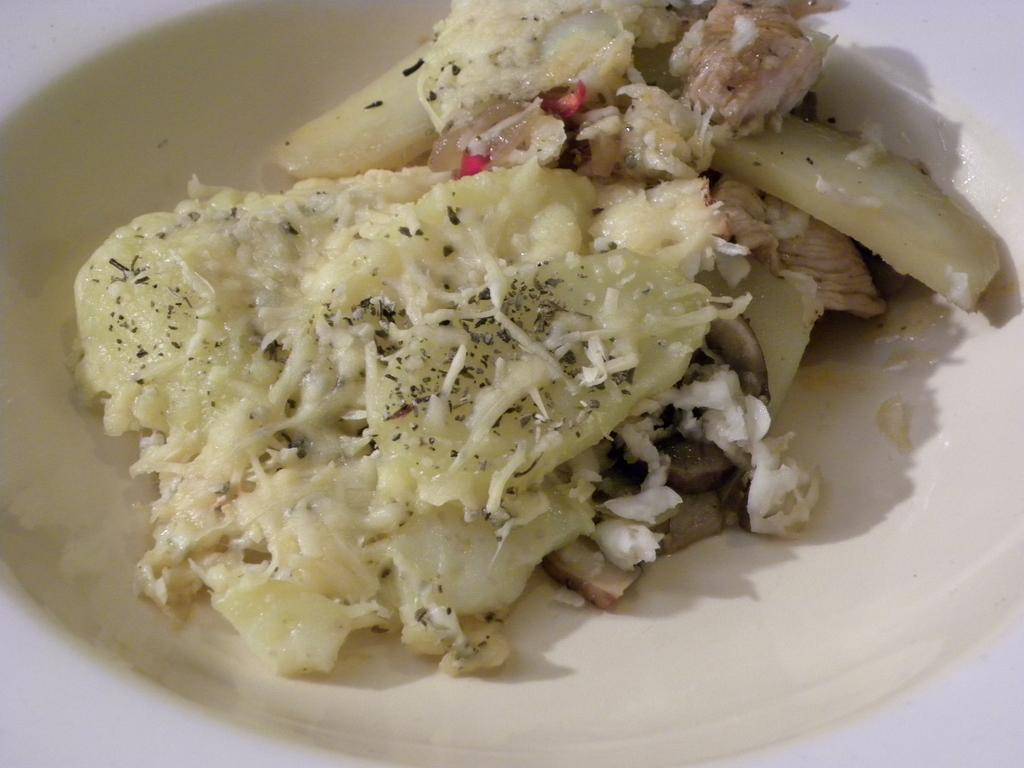What is on the plate that is visible in the image? The plate contains food. Where is the plate located in the image? The plate is placed on a surface. Can you see any toes in the image? No, there are no toes visible in the image. 